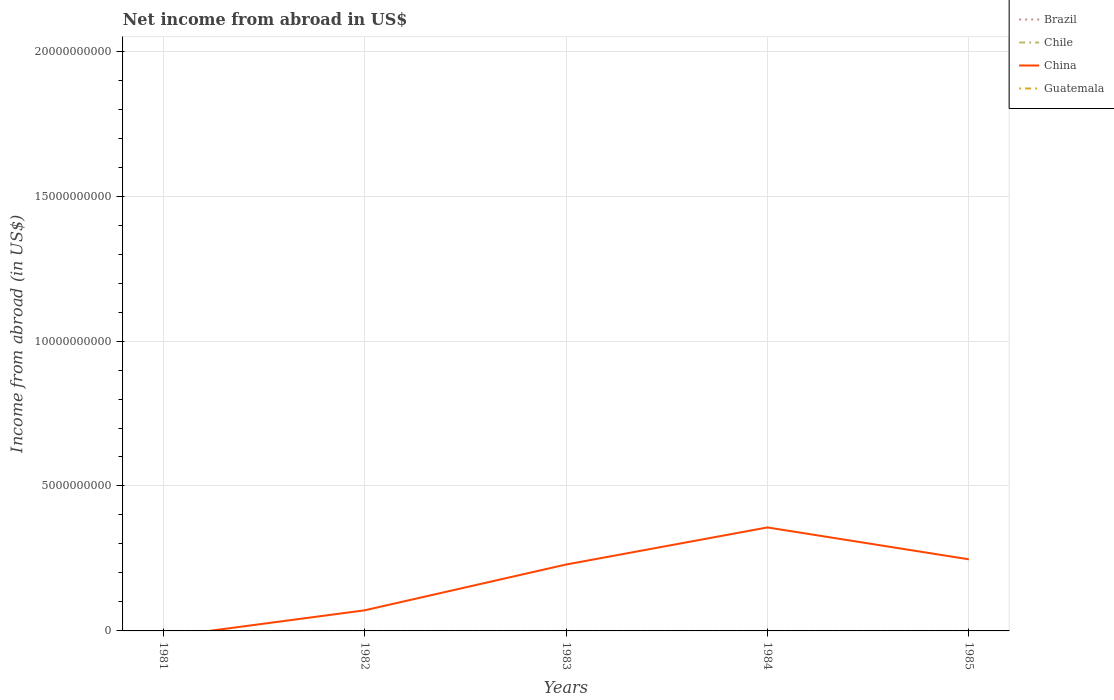Does the line corresponding to China intersect with the line corresponding to Guatemala?
Ensure brevity in your answer.  Yes. Is the number of lines equal to the number of legend labels?
Provide a succinct answer. No. What is the total net income from abroad in China in the graph?
Make the answer very short. -1.28e+09. What is the difference between the highest and the lowest net income from abroad in Guatemala?
Your response must be concise. 0. What is the difference between two consecutive major ticks on the Y-axis?
Offer a very short reply. 5.00e+09. Does the graph contain any zero values?
Provide a short and direct response. Yes. Does the graph contain grids?
Keep it short and to the point. Yes. Where does the legend appear in the graph?
Provide a succinct answer. Top right. How are the legend labels stacked?
Provide a succinct answer. Vertical. What is the title of the graph?
Provide a short and direct response. Net income from abroad in US$. Does "Europe(all income levels)" appear as one of the legend labels in the graph?
Give a very brief answer. No. What is the label or title of the Y-axis?
Provide a succinct answer. Income from abroad (in US$). What is the Income from abroad (in US$) of Chile in 1981?
Your response must be concise. 0. What is the Income from abroad (in US$) of Guatemala in 1981?
Provide a short and direct response. 0. What is the Income from abroad (in US$) in Brazil in 1982?
Provide a succinct answer. 0. What is the Income from abroad (in US$) of China in 1982?
Provide a succinct answer. 7.10e+08. What is the Income from abroad (in US$) in Brazil in 1983?
Offer a very short reply. 0. What is the Income from abroad (in US$) of China in 1983?
Give a very brief answer. 2.29e+09. What is the Income from abroad (in US$) of Guatemala in 1983?
Your response must be concise. 0. What is the Income from abroad (in US$) of China in 1984?
Offer a very short reply. 3.57e+09. What is the Income from abroad (in US$) in Guatemala in 1984?
Your response must be concise. 0. What is the Income from abroad (in US$) in China in 1985?
Provide a short and direct response. 2.47e+09. What is the Income from abroad (in US$) in Guatemala in 1985?
Make the answer very short. 0. Across all years, what is the maximum Income from abroad (in US$) in China?
Provide a succinct answer. 3.57e+09. Across all years, what is the minimum Income from abroad (in US$) in China?
Give a very brief answer. 0. What is the total Income from abroad (in US$) of Chile in the graph?
Your answer should be compact. 0. What is the total Income from abroad (in US$) in China in the graph?
Offer a very short reply. 9.04e+09. What is the total Income from abroad (in US$) of Guatemala in the graph?
Give a very brief answer. 0. What is the difference between the Income from abroad (in US$) of China in 1982 and that in 1983?
Provide a succinct answer. -1.58e+09. What is the difference between the Income from abroad (in US$) in China in 1982 and that in 1984?
Make the answer very short. -2.86e+09. What is the difference between the Income from abroad (in US$) in China in 1982 and that in 1985?
Keep it short and to the point. -1.76e+09. What is the difference between the Income from abroad (in US$) in China in 1983 and that in 1984?
Offer a very short reply. -1.28e+09. What is the difference between the Income from abroad (in US$) in China in 1983 and that in 1985?
Your response must be concise. -1.80e+08. What is the difference between the Income from abroad (in US$) of China in 1984 and that in 1985?
Your answer should be compact. 1.10e+09. What is the average Income from abroad (in US$) of China per year?
Keep it short and to the point. 1.81e+09. What is the average Income from abroad (in US$) in Guatemala per year?
Offer a terse response. 0. What is the ratio of the Income from abroad (in US$) of China in 1982 to that in 1983?
Give a very brief answer. 0.31. What is the ratio of the Income from abroad (in US$) of China in 1982 to that in 1984?
Make the answer very short. 0.2. What is the ratio of the Income from abroad (in US$) in China in 1982 to that in 1985?
Make the answer very short. 0.29. What is the ratio of the Income from abroad (in US$) in China in 1983 to that in 1984?
Keep it short and to the point. 0.64. What is the ratio of the Income from abroad (in US$) in China in 1983 to that in 1985?
Make the answer very short. 0.93. What is the ratio of the Income from abroad (in US$) of China in 1984 to that in 1985?
Ensure brevity in your answer.  1.45. What is the difference between the highest and the second highest Income from abroad (in US$) of China?
Your answer should be compact. 1.10e+09. What is the difference between the highest and the lowest Income from abroad (in US$) in China?
Ensure brevity in your answer.  3.57e+09. 